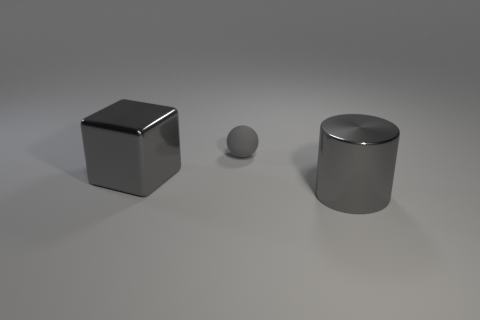Can you tell me the materials these objects might be made of? The objects in the image have a reflective surface, suggestive of metallic materials. The cube and cylinder exhibit smooth, polished surfaces, possibly stainless steel or aluminum, while the sphere has similar properties. 